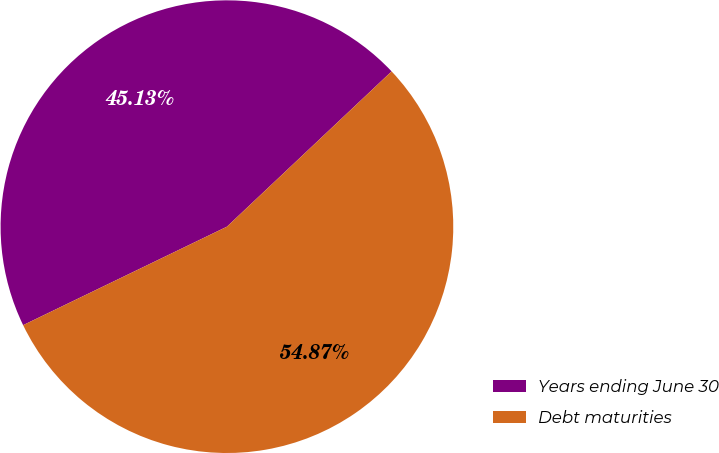Convert chart. <chart><loc_0><loc_0><loc_500><loc_500><pie_chart><fcel>Years ending June 30<fcel>Debt maturities<nl><fcel>45.13%<fcel>54.87%<nl></chart> 